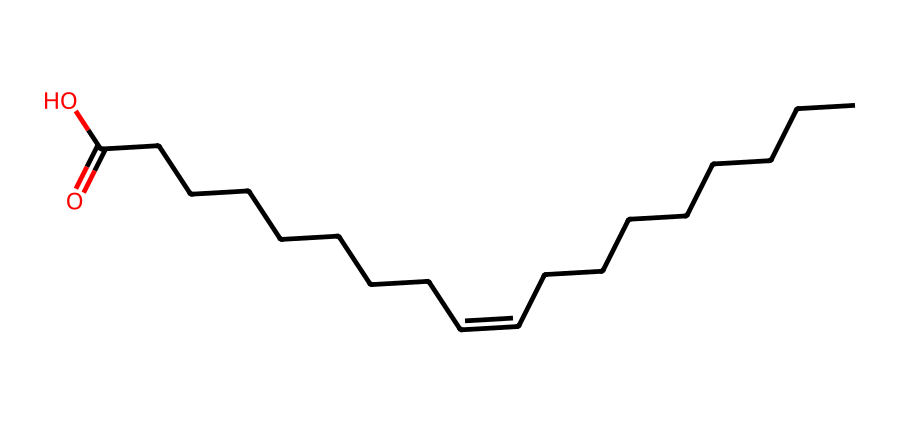What type of bond is present in the chemical structure? The chemical structure contains a double bond, indicated by the "/C=C\" portion, signifying the presence of a cis or trans configuration.
Answer: double bond How many carbon atoms are in the fatty acid? By counting the number of 'C' in the SMILES representation, we see there are 18 carbon atoms total (considering both sides of the double bond).
Answer: eighteen What is the functional group present in this fatty acid? The chemical displays a carboxylic acid functional group, characterized by the "CCCCCCCC(=O)O" part, where the "=O" and "O" denote the carbonyl and hydroxyl groups, respectively.
Answer: carboxylic acid Is this fatty acid likely to be saturated or unsaturated? The presence of a double bond indicates that this fatty acid is unsaturated, as saturated fatty acids have only single bonds.
Answer: unsaturated What is the significance of cis-trans isomerism in this fatty acid? The configuration (cis or trans) affects the physical properties, such as melting point and biological function, which is crucial in health-related contexts.
Answer: affects health properties Which configuration (cis or trans) does this fatty acid represent? From the structure "/C=C\", one can infer that it is in the cis configuration because the two hydrogen atoms are on the same side of the double bond.
Answer: cis 